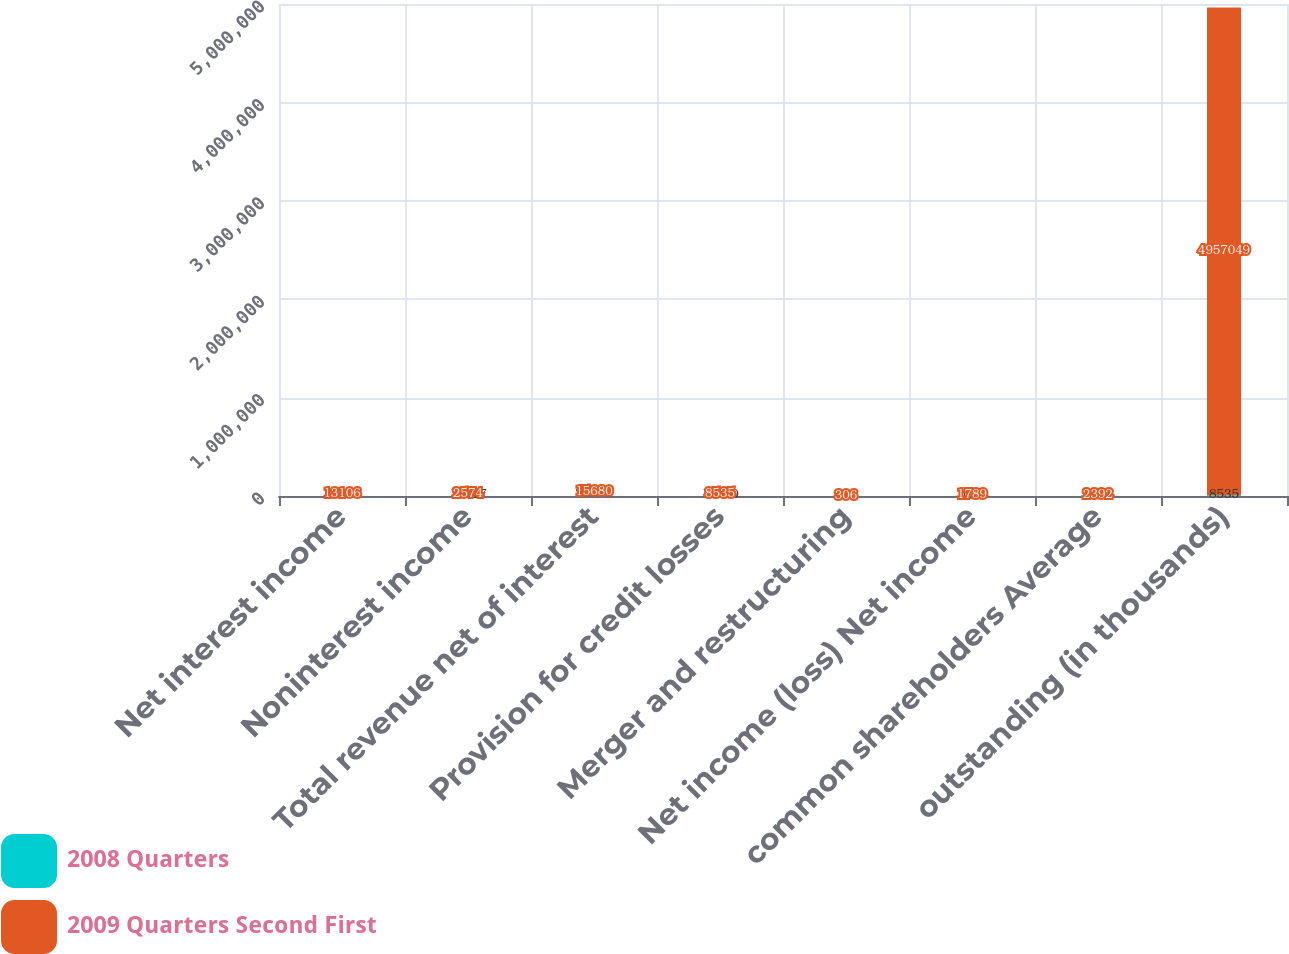<chart> <loc_0><loc_0><loc_500><loc_500><stacked_bar_chart><ecel><fcel>Net interest income<fcel>Noninterest income<fcel>Total revenue net of interest<fcel>Provision for credit losses<fcel>Merger and restructuring<fcel>Net income (loss) Net income<fcel>common shareholders Average<fcel>outstanding (in thousands)<nl><fcel>2008 Quarters<fcel>11559<fcel>13517<fcel>25076<fcel>10110<fcel>533<fcel>194<fcel>5196<fcel>8535<nl><fcel>2009 Quarters Second First<fcel>13106<fcel>2574<fcel>15680<fcel>8535<fcel>306<fcel>1789<fcel>2392<fcel>4.95705e+06<nl></chart> 